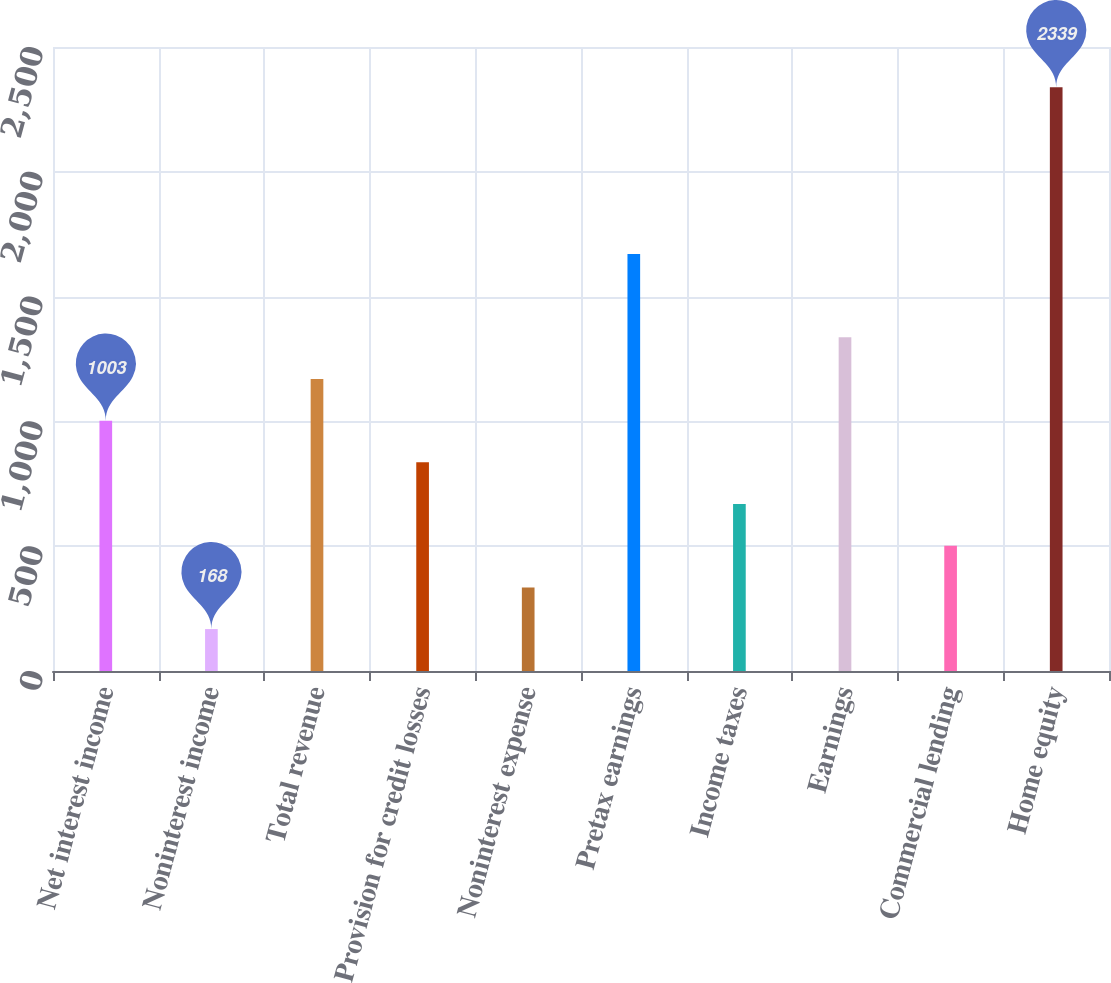Convert chart to OTSL. <chart><loc_0><loc_0><loc_500><loc_500><bar_chart><fcel>Net interest income<fcel>Noninterest income<fcel>Total revenue<fcel>Provision for credit losses<fcel>Noninterest expense<fcel>Pretax earnings<fcel>Income taxes<fcel>Earnings<fcel>Commercial lending<fcel>Home equity<nl><fcel>1003<fcel>168<fcel>1170<fcel>836<fcel>335<fcel>1671<fcel>669<fcel>1337<fcel>502<fcel>2339<nl></chart> 